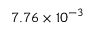<formula> <loc_0><loc_0><loc_500><loc_500>7 . 7 6 \times 1 0 ^ { - 3 }</formula> 